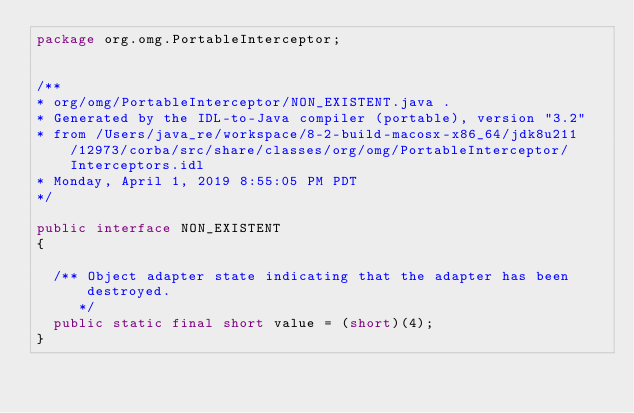Convert code to text. <code><loc_0><loc_0><loc_500><loc_500><_Java_>package org.omg.PortableInterceptor;


/**
* org/omg/PortableInterceptor/NON_EXISTENT.java .
* Generated by the IDL-to-Java compiler (portable), version "3.2"
* from /Users/java_re/workspace/8-2-build-macosx-x86_64/jdk8u211/12973/corba/src/share/classes/org/omg/PortableInterceptor/Interceptors.idl
* Monday, April 1, 2019 8:55:05 PM PDT
*/

public interface NON_EXISTENT
{

  /** Object adapter state indicating that the adapter has been destroyed.
     */
  public static final short value = (short)(4);
}
</code> 